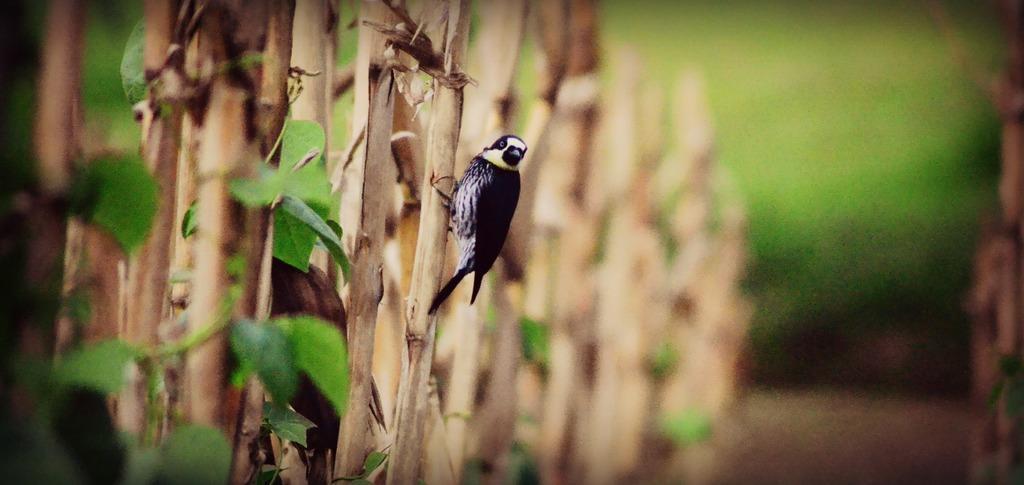Please provide a concise description of this image. There is a bird in black and white color combination standing on the branch of a tree which is having green color leaves. And the background is blurred. 